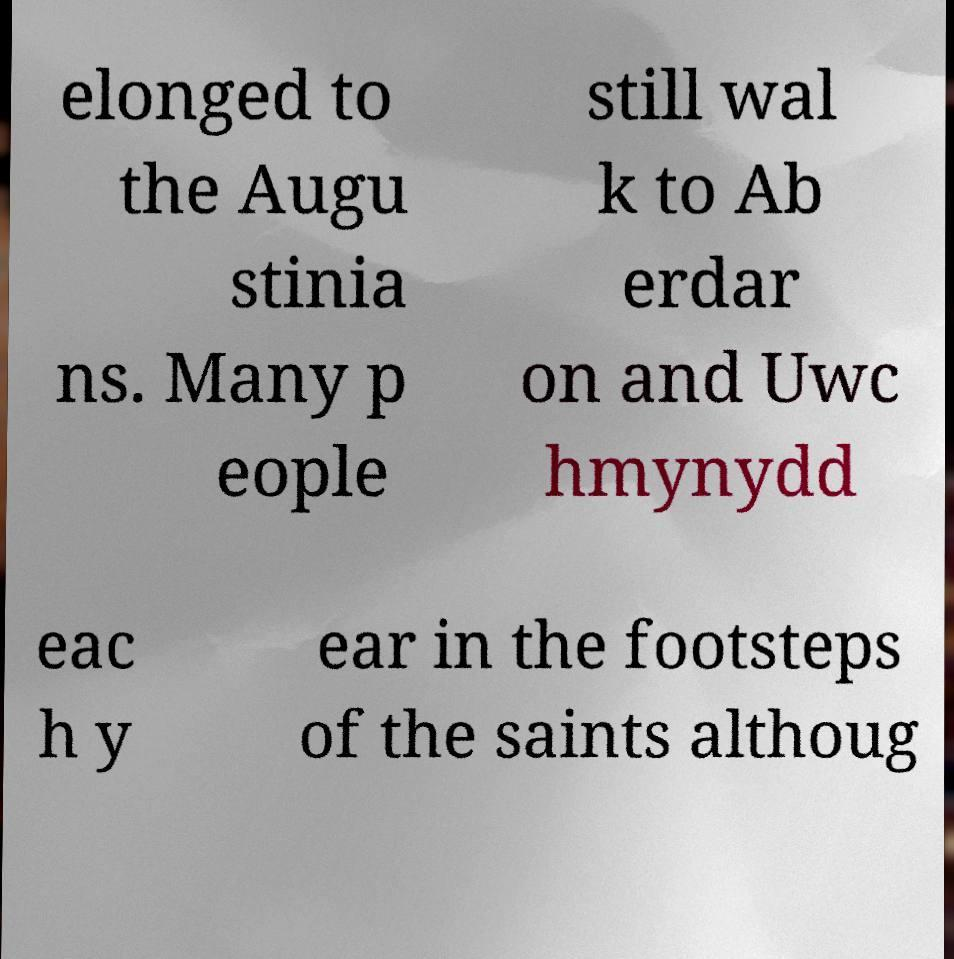Could you extract and type out the text from this image? elonged to the Augu stinia ns. Many p eople still wal k to Ab erdar on and Uwc hmynydd eac h y ear in the footsteps of the saints althoug 